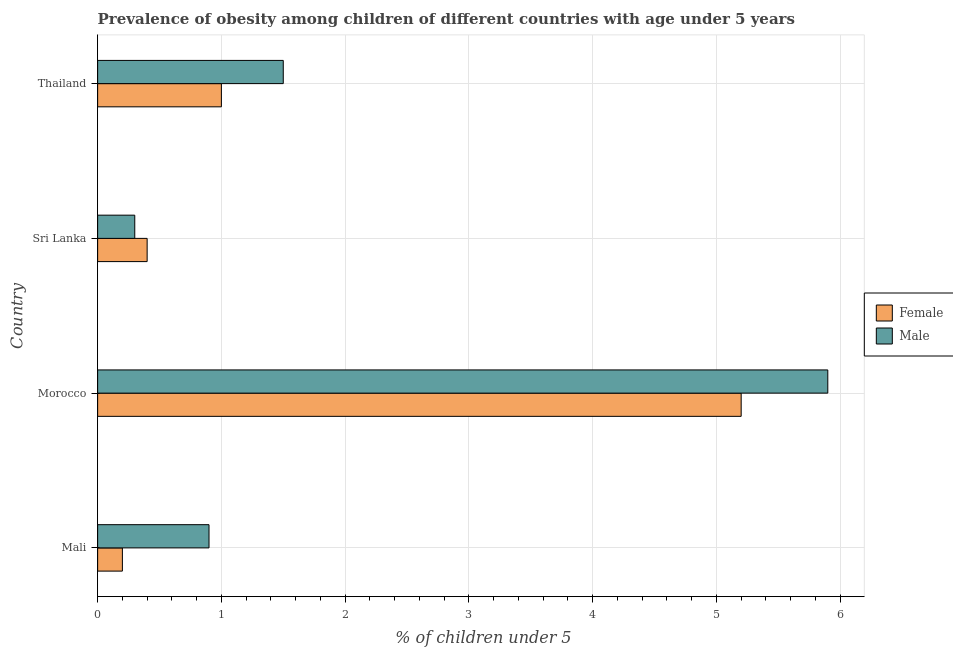Are the number of bars per tick equal to the number of legend labels?
Offer a very short reply. Yes. What is the label of the 3rd group of bars from the top?
Your answer should be compact. Morocco. In how many cases, is the number of bars for a given country not equal to the number of legend labels?
Give a very brief answer. 0. What is the percentage of obese male children in Sri Lanka?
Your answer should be compact. 0.3. Across all countries, what is the maximum percentage of obese male children?
Your answer should be very brief. 5.9. Across all countries, what is the minimum percentage of obese male children?
Keep it short and to the point. 0.3. In which country was the percentage of obese female children maximum?
Provide a short and direct response. Morocco. In which country was the percentage of obese female children minimum?
Provide a short and direct response. Mali. What is the total percentage of obese male children in the graph?
Your answer should be very brief. 8.6. What is the difference between the percentage of obese male children in Morocco and that in Thailand?
Offer a very short reply. 4.4. What is the difference between the percentage of obese male children in Sri Lanka and the percentage of obese female children in Morocco?
Provide a succinct answer. -4.9. What is the average percentage of obese female children per country?
Keep it short and to the point. 1.7. What is the difference between the percentage of obese female children and percentage of obese male children in Morocco?
Your response must be concise. -0.7. What is the ratio of the percentage of obese female children in Mali to that in Thailand?
Keep it short and to the point. 0.2. Is the percentage of obese male children in Mali less than that in Thailand?
Give a very brief answer. Yes. What is the difference between the highest and the second highest percentage of obese female children?
Provide a short and direct response. 4.2. What is the difference between the highest and the lowest percentage of obese female children?
Offer a terse response. 5. What does the 2nd bar from the top in Mali represents?
Give a very brief answer. Female. Are all the bars in the graph horizontal?
Your answer should be compact. Yes. How many countries are there in the graph?
Provide a short and direct response. 4. What is the difference between two consecutive major ticks on the X-axis?
Your answer should be very brief. 1. Does the graph contain grids?
Your response must be concise. Yes. What is the title of the graph?
Provide a succinct answer. Prevalence of obesity among children of different countries with age under 5 years. Does "Female labourers" appear as one of the legend labels in the graph?
Ensure brevity in your answer.  No. What is the label or title of the X-axis?
Provide a short and direct response.  % of children under 5. What is the  % of children under 5 in Female in Mali?
Provide a succinct answer. 0.2. What is the  % of children under 5 in Male in Mali?
Provide a short and direct response. 0.9. What is the  % of children under 5 of Female in Morocco?
Provide a succinct answer. 5.2. What is the  % of children under 5 in Male in Morocco?
Offer a terse response. 5.9. What is the  % of children under 5 in Female in Sri Lanka?
Give a very brief answer. 0.4. What is the  % of children under 5 of Male in Sri Lanka?
Ensure brevity in your answer.  0.3. What is the  % of children under 5 in Female in Thailand?
Your response must be concise. 1. Across all countries, what is the maximum  % of children under 5 of Female?
Keep it short and to the point. 5.2. Across all countries, what is the maximum  % of children under 5 of Male?
Make the answer very short. 5.9. Across all countries, what is the minimum  % of children under 5 in Female?
Ensure brevity in your answer.  0.2. Across all countries, what is the minimum  % of children under 5 of Male?
Offer a terse response. 0.3. What is the total  % of children under 5 of Male in the graph?
Offer a terse response. 8.6. What is the difference between the  % of children under 5 of Female in Mali and that in Morocco?
Make the answer very short. -5. What is the difference between the  % of children under 5 of Female in Mali and that in Sri Lanka?
Offer a terse response. -0.2. What is the difference between the  % of children under 5 in Male in Mali and that in Sri Lanka?
Provide a short and direct response. 0.6. What is the difference between the  % of children under 5 in Male in Mali and that in Thailand?
Offer a very short reply. -0.6. What is the difference between the  % of children under 5 in Female in Morocco and that in Sri Lanka?
Offer a terse response. 4.8. What is the difference between the  % of children under 5 in Female in Sri Lanka and that in Thailand?
Provide a succinct answer. -0.6. What is the difference between the  % of children under 5 of Male in Sri Lanka and that in Thailand?
Keep it short and to the point. -1.2. What is the difference between the  % of children under 5 of Female in Mali and the  % of children under 5 of Male in Sri Lanka?
Your answer should be very brief. -0.1. What is the difference between the  % of children under 5 of Female in Morocco and the  % of children under 5 of Male in Sri Lanka?
Offer a very short reply. 4.9. What is the difference between the  % of children under 5 in Female in Sri Lanka and the  % of children under 5 in Male in Thailand?
Your answer should be very brief. -1.1. What is the average  % of children under 5 of Male per country?
Your answer should be compact. 2.15. What is the difference between the  % of children under 5 of Female and  % of children under 5 of Male in Mali?
Keep it short and to the point. -0.7. What is the difference between the  % of children under 5 in Female and  % of children under 5 in Male in Morocco?
Give a very brief answer. -0.7. What is the difference between the  % of children under 5 in Female and  % of children under 5 in Male in Sri Lanka?
Ensure brevity in your answer.  0.1. What is the difference between the  % of children under 5 of Female and  % of children under 5 of Male in Thailand?
Give a very brief answer. -0.5. What is the ratio of the  % of children under 5 of Female in Mali to that in Morocco?
Your answer should be very brief. 0.04. What is the ratio of the  % of children under 5 in Male in Mali to that in Morocco?
Keep it short and to the point. 0.15. What is the ratio of the  % of children under 5 in Female in Mali to that in Sri Lanka?
Your answer should be very brief. 0.5. What is the ratio of the  % of children under 5 in Female in Mali to that in Thailand?
Offer a very short reply. 0.2. What is the ratio of the  % of children under 5 in Male in Mali to that in Thailand?
Your response must be concise. 0.6. What is the ratio of the  % of children under 5 in Female in Morocco to that in Sri Lanka?
Provide a succinct answer. 13. What is the ratio of the  % of children under 5 of Male in Morocco to that in Sri Lanka?
Your response must be concise. 19.67. What is the ratio of the  % of children under 5 of Male in Morocco to that in Thailand?
Offer a very short reply. 3.93. What is the ratio of the  % of children under 5 in Male in Sri Lanka to that in Thailand?
Provide a short and direct response. 0.2. What is the difference between the highest and the second highest  % of children under 5 of Female?
Offer a very short reply. 4.2. What is the difference between the highest and the second highest  % of children under 5 in Male?
Provide a short and direct response. 4.4. What is the difference between the highest and the lowest  % of children under 5 of Female?
Provide a succinct answer. 5. 